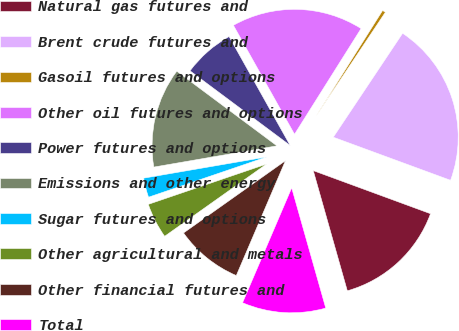Convert chart. <chart><loc_0><loc_0><loc_500><loc_500><pie_chart><fcel>Natural gas futures and<fcel>Brent crude futures and<fcel>Gasoil futures and options<fcel>Other oil futures and options<fcel>Power futures and options<fcel>Emissions and other energy<fcel>Sugar futures and options<fcel>Other agricultural and metals<fcel>Other financial futures and<fcel>Total<nl><fcel>15.0%<fcel>21.24%<fcel>0.42%<fcel>17.08%<fcel>6.67%<fcel>12.91%<fcel>2.51%<fcel>4.59%<fcel>8.75%<fcel>10.83%<nl></chart> 